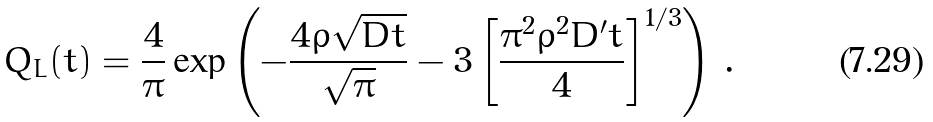<formula> <loc_0><loc_0><loc_500><loc_500>Q _ { L } ( t ) = \frac { 4 } { \pi } \exp \left ( - \frac { 4 \rho \sqrt { D t } } { \sqrt { \pi } } - 3 \left [ \frac { \pi ^ { 2 } \rho ^ { 2 } D ^ { \prime } t } { 4 } \right ] ^ { 1 / 3 } \right ) \, .</formula> 